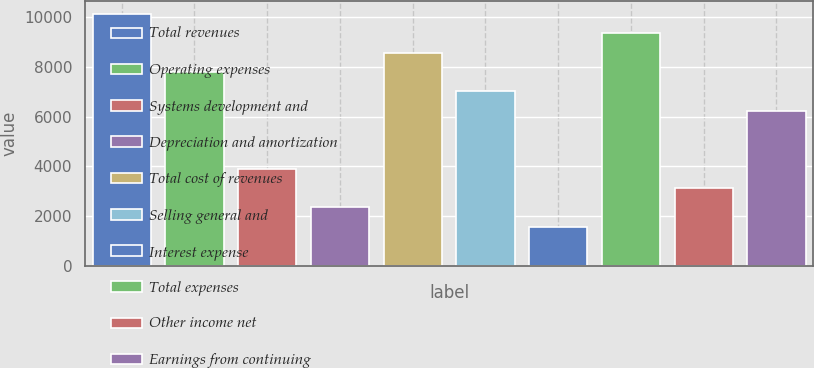Convert chart. <chart><loc_0><loc_0><loc_500><loc_500><bar_chart><fcel>Total revenues<fcel>Operating expenses<fcel>Systems development and<fcel>Depreciation and amortization<fcel>Total cost of revenues<fcel>Selling general and<fcel>Interest expense<fcel>Total expenses<fcel>Other income net<fcel>Earnings from continuing<nl><fcel>10139.5<fcel>7800.03<fcel>3900.93<fcel>2341.29<fcel>8579.85<fcel>7020.21<fcel>1561.47<fcel>9359.67<fcel>3121.11<fcel>6240.39<nl></chart> 